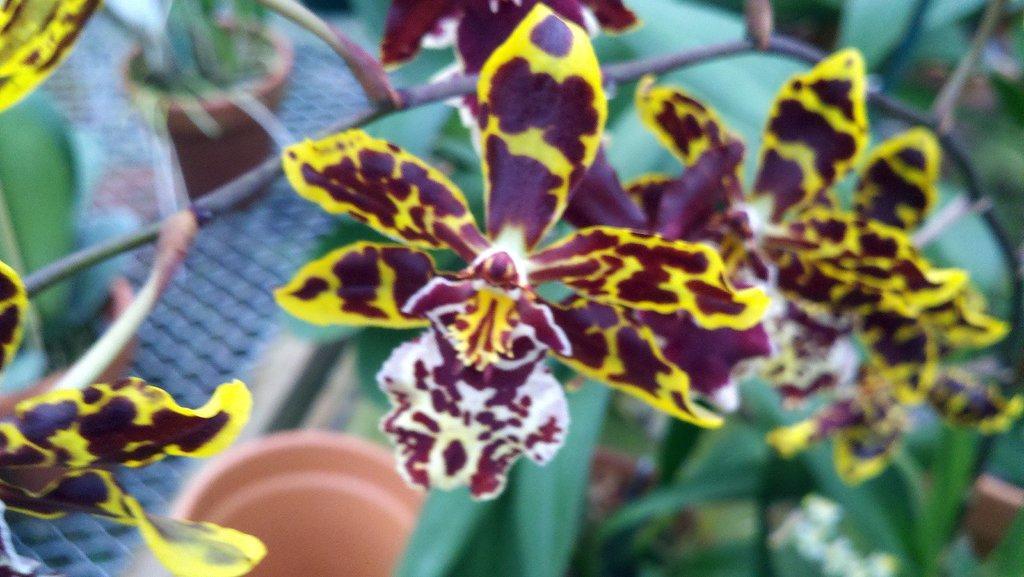In one or two sentences, can you explain what this image depicts? In this image I can see flowering plants and pots on the floor. This image is taken may be during a day. 